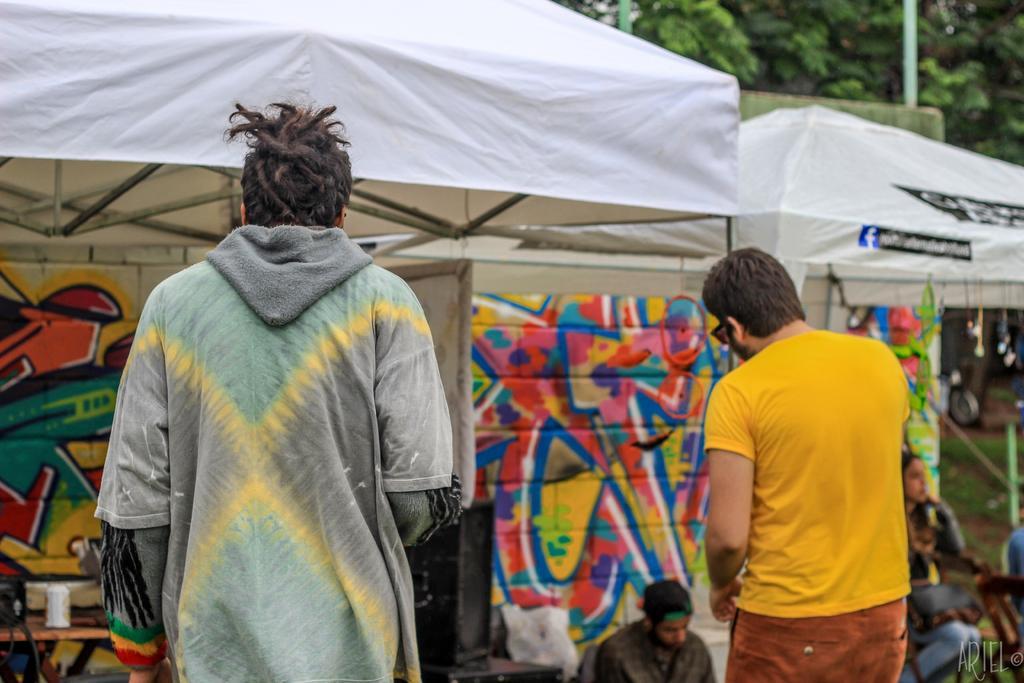In one or two sentences, can you explain what this image depicts? In the center of the image there are two people standing. In the background of the image there are stalls. There are trees. 